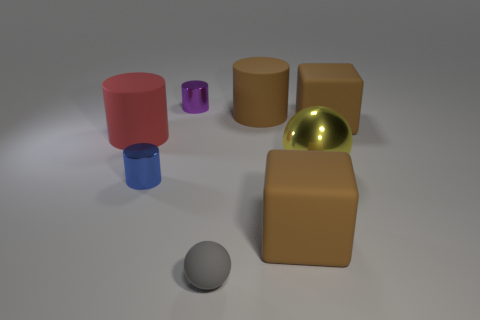Can you tell me the colors of the various objects in the image? Certainly! In the image, there is a pink cylinder, a small purple cylinder, a blue cylinder, two matte beige cylinders, and a shiny yellow metallic ball. There's also a small grey sphere on the ground. 